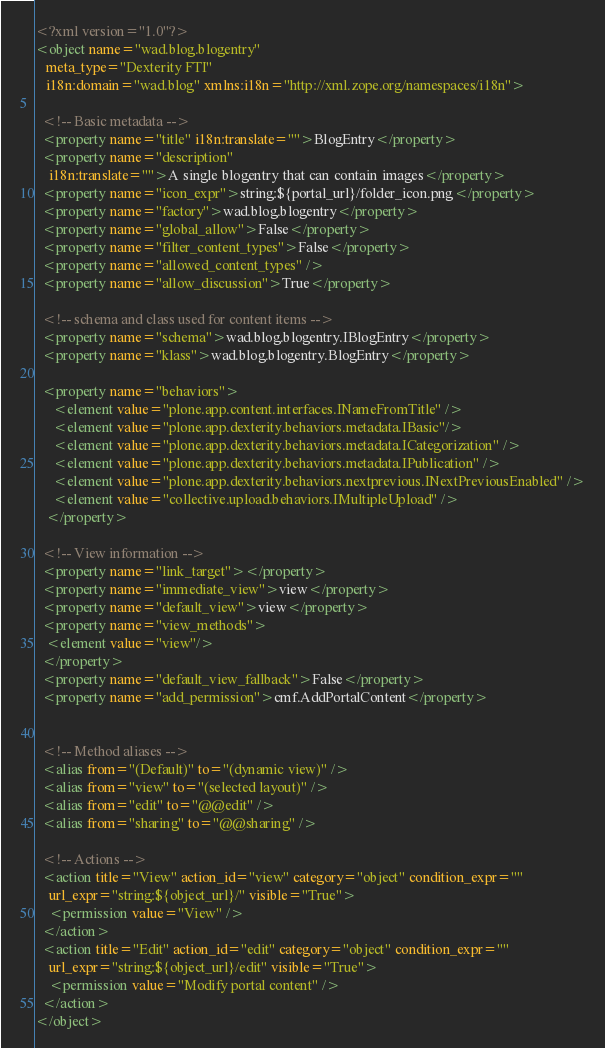<code> <loc_0><loc_0><loc_500><loc_500><_XML_><?xml version="1.0"?>
<object name="wad.blog.blogentry"
   meta_type="Dexterity FTI"
   i18n:domain="wad.blog" xmlns:i18n="http://xml.zope.org/namespaces/i18n">

  <!-- Basic metadata -->
  <property name="title" i18n:translate="">BlogEntry</property>
  <property name="description"
    i18n:translate="">A single blogentry that can contain images</property>
  <property name="icon_expr">string:${portal_url}/folder_icon.png</property>
  <property name="factory">wad.blog.blogentry</property>
  <property name="global_allow">False</property>
  <property name="filter_content_types">False</property>  
  <property name="allowed_content_types" />
  <property name="allow_discussion">True</property>

  <!-- schema and class used for content items -->
  <property name="schema">wad.blog.blogentry.IBlogEntry</property> 
  <property name="klass">wad.blog.blogentry.BlogEntry</property>

  <property name="behaviors">
     <element value="plone.app.content.interfaces.INameFromTitle" />
     <element value="plone.app.dexterity.behaviors.metadata.IBasic"/>
     <element value="plone.app.dexterity.behaviors.metadata.ICategorization" />
     <element value="plone.app.dexterity.behaviors.metadata.IPublication" />
     <element value="plone.app.dexterity.behaviors.nextprevious.INextPreviousEnabled" />
     <element value="collective.upload.behaviors.IMultipleUpload" />
   </property>

  <!-- View information -->
  <property name="link_target"></property>
  <property name="immediate_view">view</property>
  <property name="default_view">view</property>
  <property name="view_methods">
   <element value="view"/>
  </property>
  <property name="default_view_fallback">False</property>
  <property name="add_permission">cmf.AddPortalContent</property>


  <!-- Method aliases -->
  <alias from="(Default)" to="(dynamic view)" />
  <alias from="view" to="(selected layout)" />
  <alias from="edit" to="@@edit" />
  <alias from="sharing" to="@@sharing" />

  <!-- Actions -->
  <action title="View" action_id="view" category="object" condition_expr=""
    url_expr="string:${object_url}/" visible="True">
    <permission value="View" />
  </action>
  <action title="Edit" action_id="edit" category="object" condition_expr=""
    url_expr="string:${object_url}/edit" visible="True">
    <permission value="Modify portal content" />
  </action>
</object>
</code> 